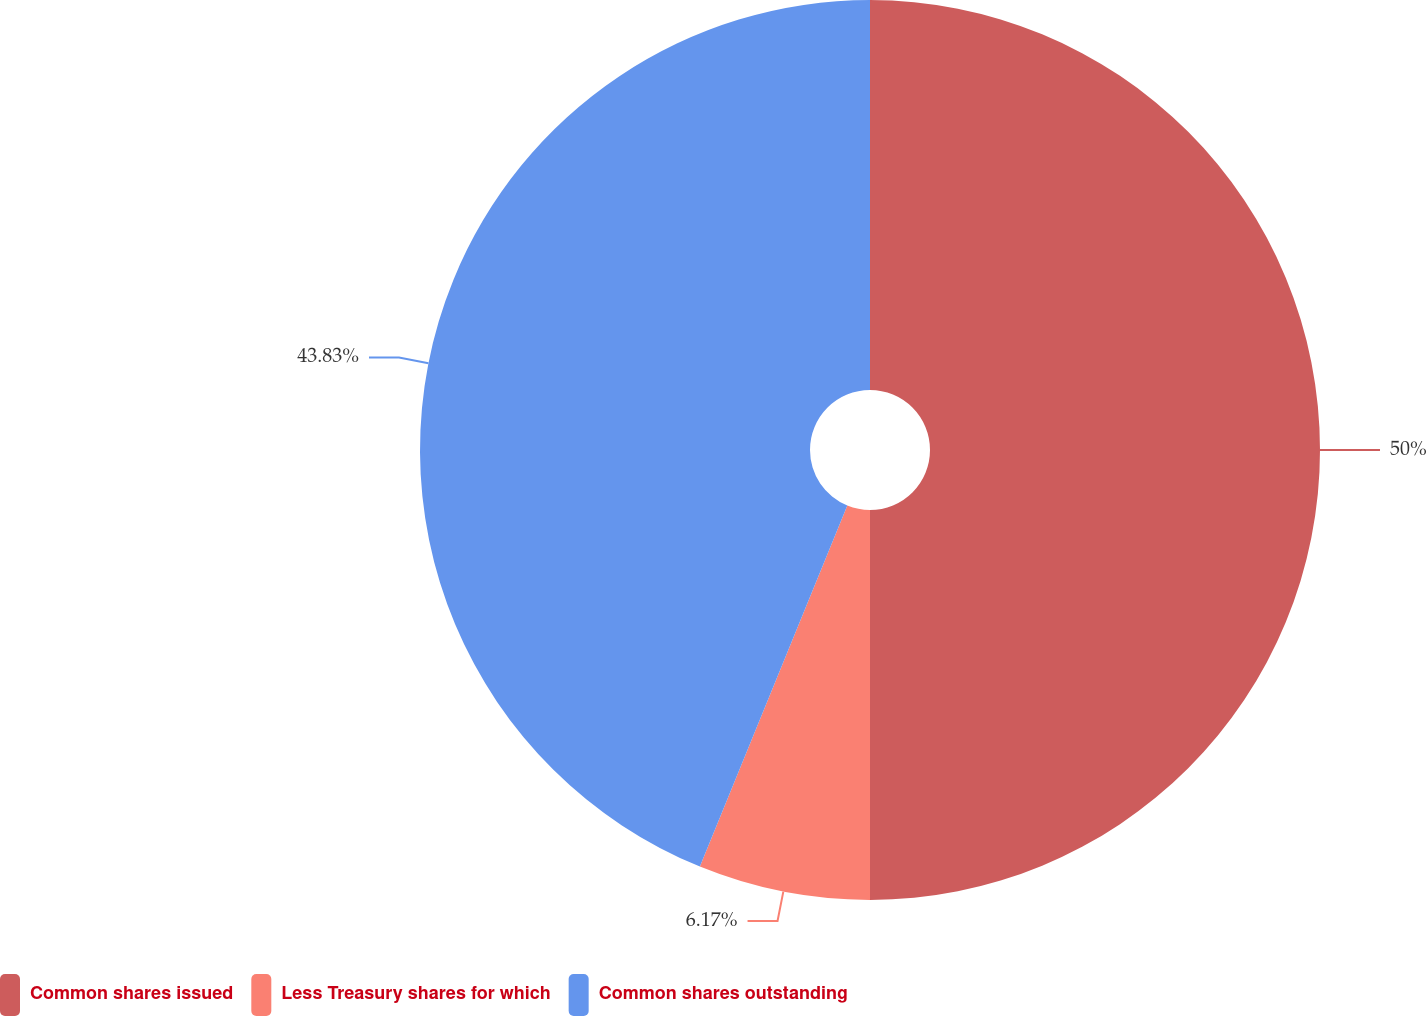Convert chart to OTSL. <chart><loc_0><loc_0><loc_500><loc_500><pie_chart><fcel>Common shares issued<fcel>Less Treasury shares for which<fcel>Common shares outstanding<nl><fcel>50.0%<fcel>6.17%<fcel>43.83%<nl></chart> 